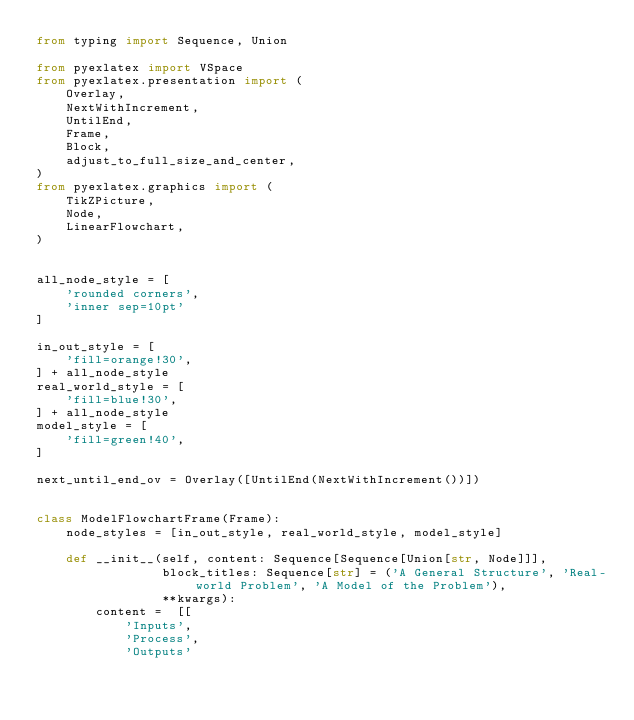<code> <loc_0><loc_0><loc_500><loc_500><_Python_>from typing import Sequence, Union

from pyexlatex import VSpace
from pyexlatex.presentation import (
    Overlay,
    NextWithIncrement,
    UntilEnd,
    Frame,
    Block,
    adjust_to_full_size_and_center,
)
from pyexlatex.graphics import (
    TikZPicture,
    Node,
    LinearFlowchart,
)


all_node_style = [
    'rounded corners',
    'inner sep=10pt'
]

in_out_style = [
    'fill=orange!30',
] + all_node_style
real_world_style = [
    'fill=blue!30',
] + all_node_style
model_style = [
    'fill=green!40',
]

next_until_end_ov = Overlay([UntilEnd(NextWithIncrement())])


class ModelFlowchartFrame(Frame):
    node_styles = [in_out_style, real_world_style, model_style]

    def __init__(self, content: Sequence[Sequence[Union[str, Node]]],
                 block_titles: Sequence[str] = ('A General Structure', 'Real-world Problem', 'A Model of the Problem'),
                 **kwargs):
        content =  [[
            'Inputs',
            'Process',
            'Outputs'</code> 